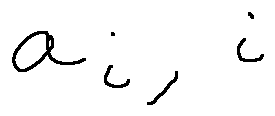<formula> <loc_0><loc_0><loc_500><loc_500>a _ { i , i }</formula> 